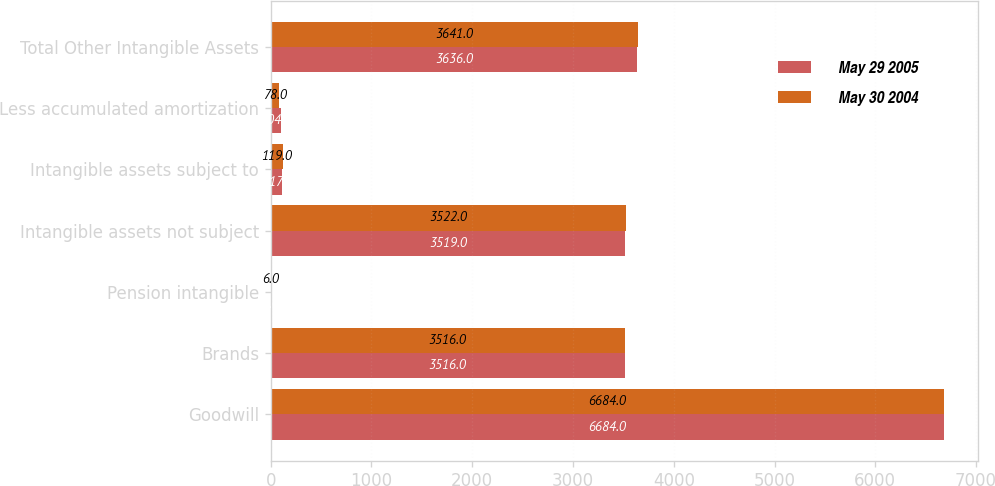Convert chart to OTSL. <chart><loc_0><loc_0><loc_500><loc_500><stacked_bar_chart><ecel><fcel>Goodwill<fcel>Brands<fcel>Pension intangible<fcel>Intangible assets not subject<fcel>Intangible assets subject to<fcel>Less accumulated amortization<fcel>Total Other Intangible Assets<nl><fcel>May 29 2005<fcel>6684<fcel>3516<fcel>3<fcel>3519<fcel>117<fcel>104<fcel>3636<nl><fcel>May 30 2004<fcel>6684<fcel>3516<fcel>6<fcel>3522<fcel>119<fcel>78<fcel>3641<nl></chart> 